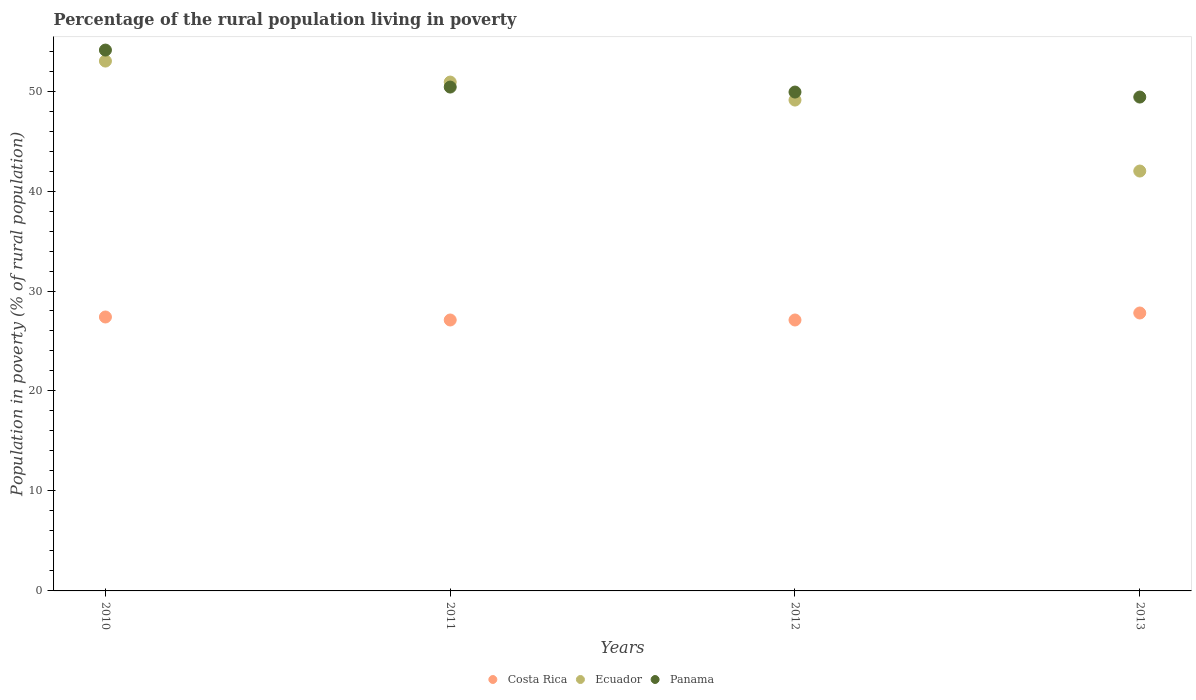Across all years, what is the maximum percentage of the rural population living in poverty in Costa Rica?
Provide a short and direct response. 27.8. Across all years, what is the minimum percentage of the rural population living in poverty in Panama?
Offer a very short reply. 49.4. What is the total percentage of the rural population living in poverty in Panama in the graph?
Your answer should be compact. 203.8. What is the difference between the percentage of the rural population living in poverty in Ecuador in 2010 and that in 2012?
Offer a very short reply. 3.9. What is the average percentage of the rural population living in poverty in Panama per year?
Keep it short and to the point. 50.95. In the year 2010, what is the difference between the percentage of the rural population living in poverty in Ecuador and percentage of the rural population living in poverty in Panama?
Provide a succinct answer. -1.1. What is the ratio of the percentage of the rural population living in poverty in Costa Rica in 2010 to that in 2011?
Your answer should be very brief. 1.01. Is the percentage of the rural population living in poverty in Ecuador in 2011 less than that in 2013?
Your answer should be very brief. No. Is the difference between the percentage of the rural population living in poverty in Ecuador in 2010 and 2012 greater than the difference between the percentage of the rural population living in poverty in Panama in 2010 and 2012?
Make the answer very short. No. What is the difference between the highest and the second highest percentage of the rural population living in poverty in Panama?
Ensure brevity in your answer.  3.7. In how many years, is the percentage of the rural population living in poverty in Panama greater than the average percentage of the rural population living in poverty in Panama taken over all years?
Keep it short and to the point. 1. Is it the case that in every year, the sum of the percentage of the rural population living in poverty in Costa Rica and percentage of the rural population living in poverty in Ecuador  is greater than the percentage of the rural population living in poverty in Panama?
Give a very brief answer. Yes. Is the percentage of the rural population living in poverty in Ecuador strictly greater than the percentage of the rural population living in poverty in Panama over the years?
Your answer should be very brief. No. How many dotlines are there?
Offer a very short reply. 3. How many years are there in the graph?
Offer a terse response. 4. Does the graph contain grids?
Make the answer very short. No. Where does the legend appear in the graph?
Provide a succinct answer. Bottom center. How are the legend labels stacked?
Your answer should be compact. Horizontal. What is the title of the graph?
Your answer should be very brief. Percentage of the rural population living in poverty. What is the label or title of the Y-axis?
Your response must be concise. Population in poverty (% of rural population). What is the Population in poverty (% of rural population) of Costa Rica in 2010?
Your response must be concise. 27.4. What is the Population in poverty (% of rural population) of Panama in 2010?
Provide a succinct answer. 54.1. What is the Population in poverty (% of rural population) of Costa Rica in 2011?
Make the answer very short. 27.1. What is the Population in poverty (% of rural population) of Ecuador in 2011?
Give a very brief answer. 50.9. What is the Population in poverty (% of rural population) in Panama in 2011?
Provide a short and direct response. 50.4. What is the Population in poverty (% of rural population) in Costa Rica in 2012?
Your response must be concise. 27.1. What is the Population in poverty (% of rural population) in Ecuador in 2012?
Ensure brevity in your answer.  49.1. What is the Population in poverty (% of rural population) of Panama in 2012?
Ensure brevity in your answer.  49.9. What is the Population in poverty (% of rural population) of Costa Rica in 2013?
Your answer should be very brief. 27.8. What is the Population in poverty (% of rural population) of Panama in 2013?
Make the answer very short. 49.4. Across all years, what is the maximum Population in poverty (% of rural population) of Costa Rica?
Your answer should be very brief. 27.8. Across all years, what is the maximum Population in poverty (% of rural population) in Ecuador?
Provide a short and direct response. 53. Across all years, what is the maximum Population in poverty (% of rural population) in Panama?
Offer a very short reply. 54.1. Across all years, what is the minimum Population in poverty (% of rural population) of Costa Rica?
Offer a terse response. 27.1. Across all years, what is the minimum Population in poverty (% of rural population) in Ecuador?
Make the answer very short. 42. Across all years, what is the minimum Population in poverty (% of rural population) of Panama?
Make the answer very short. 49.4. What is the total Population in poverty (% of rural population) in Costa Rica in the graph?
Make the answer very short. 109.4. What is the total Population in poverty (% of rural population) in Ecuador in the graph?
Your answer should be compact. 195. What is the total Population in poverty (% of rural population) of Panama in the graph?
Your response must be concise. 203.8. What is the difference between the Population in poverty (% of rural population) in Costa Rica in 2010 and that in 2011?
Make the answer very short. 0.3. What is the difference between the Population in poverty (% of rural population) in Panama in 2010 and that in 2011?
Ensure brevity in your answer.  3.7. What is the difference between the Population in poverty (% of rural population) of Costa Rica in 2010 and that in 2012?
Offer a terse response. 0.3. What is the difference between the Population in poverty (% of rural population) of Ecuador in 2010 and that in 2012?
Your answer should be very brief. 3.9. What is the difference between the Population in poverty (% of rural population) in Costa Rica in 2010 and that in 2013?
Offer a terse response. -0.4. What is the difference between the Population in poverty (% of rural population) in Panama in 2010 and that in 2013?
Keep it short and to the point. 4.7. What is the difference between the Population in poverty (% of rural population) in Costa Rica in 2011 and that in 2012?
Your answer should be compact. 0. What is the difference between the Population in poverty (% of rural population) of Ecuador in 2011 and that in 2012?
Your response must be concise. 1.8. What is the difference between the Population in poverty (% of rural population) of Panama in 2011 and that in 2012?
Ensure brevity in your answer.  0.5. What is the difference between the Population in poverty (% of rural population) of Ecuador in 2011 and that in 2013?
Your response must be concise. 8.9. What is the difference between the Population in poverty (% of rural population) of Costa Rica in 2012 and that in 2013?
Provide a succinct answer. -0.7. What is the difference between the Population in poverty (% of rural population) in Ecuador in 2012 and that in 2013?
Ensure brevity in your answer.  7.1. What is the difference between the Population in poverty (% of rural population) of Panama in 2012 and that in 2013?
Offer a very short reply. 0.5. What is the difference between the Population in poverty (% of rural population) in Costa Rica in 2010 and the Population in poverty (% of rural population) in Ecuador in 2011?
Offer a terse response. -23.5. What is the difference between the Population in poverty (% of rural population) of Costa Rica in 2010 and the Population in poverty (% of rural population) of Panama in 2011?
Give a very brief answer. -23. What is the difference between the Population in poverty (% of rural population) of Ecuador in 2010 and the Population in poverty (% of rural population) of Panama in 2011?
Provide a succinct answer. 2.6. What is the difference between the Population in poverty (% of rural population) of Costa Rica in 2010 and the Population in poverty (% of rural population) of Ecuador in 2012?
Your response must be concise. -21.7. What is the difference between the Population in poverty (% of rural population) of Costa Rica in 2010 and the Population in poverty (% of rural population) of Panama in 2012?
Make the answer very short. -22.5. What is the difference between the Population in poverty (% of rural population) in Costa Rica in 2010 and the Population in poverty (% of rural population) in Ecuador in 2013?
Your response must be concise. -14.6. What is the difference between the Population in poverty (% of rural population) in Costa Rica in 2011 and the Population in poverty (% of rural population) in Ecuador in 2012?
Your answer should be very brief. -22. What is the difference between the Population in poverty (% of rural population) in Costa Rica in 2011 and the Population in poverty (% of rural population) in Panama in 2012?
Ensure brevity in your answer.  -22.8. What is the difference between the Population in poverty (% of rural population) in Costa Rica in 2011 and the Population in poverty (% of rural population) in Ecuador in 2013?
Your answer should be very brief. -14.9. What is the difference between the Population in poverty (% of rural population) of Costa Rica in 2011 and the Population in poverty (% of rural population) of Panama in 2013?
Offer a very short reply. -22.3. What is the difference between the Population in poverty (% of rural population) in Costa Rica in 2012 and the Population in poverty (% of rural population) in Ecuador in 2013?
Your answer should be compact. -14.9. What is the difference between the Population in poverty (% of rural population) of Costa Rica in 2012 and the Population in poverty (% of rural population) of Panama in 2013?
Provide a succinct answer. -22.3. What is the difference between the Population in poverty (% of rural population) in Ecuador in 2012 and the Population in poverty (% of rural population) in Panama in 2013?
Provide a short and direct response. -0.3. What is the average Population in poverty (% of rural population) in Costa Rica per year?
Offer a terse response. 27.35. What is the average Population in poverty (% of rural population) in Ecuador per year?
Offer a terse response. 48.75. What is the average Population in poverty (% of rural population) of Panama per year?
Offer a terse response. 50.95. In the year 2010, what is the difference between the Population in poverty (% of rural population) in Costa Rica and Population in poverty (% of rural population) in Ecuador?
Offer a very short reply. -25.6. In the year 2010, what is the difference between the Population in poverty (% of rural population) of Costa Rica and Population in poverty (% of rural population) of Panama?
Make the answer very short. -26.7. In the year 2011, what is the difference between the Population in poverty (% of rural population) in Costa Rica and Population in poverty (% of rural population) in Ecuador?
Your answer should be very brief. -23.8. In the year 2011, what is the difference between the Population in poverty (% of rural population) of Costa Rica and Population in poverty (% of rural population) of Panama?
Your response must be concise. -23.3. In the year 2011, what is the difference between the Population in poverty (% of rural population) in Ecuador and Population in poverty (% of rural population) in Panama?
Ensure brevity in your answer.  0.5. In the year 2012, what is the difference between the Population in poverty (% of rural population) of Costa Rica and Population in poverty (% of rural population) of Ecuador?
Offer a very short reply. -22. In the year 2012, what is the difference between the Population in poverty (% of rural population) of Costa Rica and Population in poverty (% of rural population) of Panama?
Make the answer very short. -22.8. In the year 2013, what is the difference between the Population in poverty (% of rural population) in Costa Rica and Population in poverty (% of rural population) in Panama?
Ensure brevity in your answer.  -21.6. What is the ratio of the Population in poverty (% of rural population) in Costa Rica in 2010 to that in 2011?
Your answer should be compact. 1.01. What is the ratio of the Population in poverty (% of rural population) in Ecuador in 2010 to that in 2011?
Ensure brevity in your answer.  1.04. What is the ratio of the Population in poverty (% of rural population) in Panama in 2010 to that in 2011?
Provide a succinct answer. 1.07. What is the ratio of the Population in poverty (% of rural population) in Costa Rica in 2010 to that in 2012?
Your answer should be very brief. 1.01. What is the ratio of the Population in poverty (% of rural population) in Ecuador in 2010 to that in 2012?
Your answer should be very brief. 1.08. What is the ratio of the Population in poverty (% of rural population) of Panama in 2010 to that in 2012?
Provide a succinct answer. 1.08. What is the ratio of the Population in poverty (% of rural population) in Costa Rica in 2010 to that in 2013?
Make the answer very short. 0.99. What is the ratio of the Population in poverty (% of rural population) in Ecuador in 2010 to that in 2013?
Your response must be concise. 1.26. What is the ratio of the Population in poverty (% of rural population) in Panama in 2010 to that in 2013?
Offer a terse response. 1.1. What is the ratio of the Population in poverty (% of rural population) in Costa Rica in 2011 to that in 2012?
Your answer should be very brief. 1. What is the ratio of the Population in poverty (% of rural population) of Ecuador in 2011 to that in 2012?
Offer a terse response. 1.04. What is the ratio of the Population in poverty (% of rural population) in Costa Rica in 2011 to that in 2013?
Ensure brevity in your answer.  0.97. What is the ratio of the Population in poverty (% of rural population) of Ecuador in 2011 to that in 2013?
Your response must be concise. 1.21. What is the ratio of the Population in poverty (% of rural population) in Panama in 2011 to that in 2013?
Your response must be concise. 1.02. What is the ratio of the Population in poverty (% of rural population) in Costa Rica in 2012 to that in 2013?
Your answer should be very brief. 0.97. What is the ratio of the Population in poverty (% of rural population) of Ecuador in 2012 to that in 2013?
Give a very brief answer. 1.17. What is the ratio of the Population in poverty (% of rural population) of Panama in 2012 to that in 2013?
Your response must be concise. 1.01. What is the difference between the highest and the second highest Population in poverty (% of rural population) of Costa Rica?
Make the answer very short. 0.4. What is the difference between the highest and the second highest Population in poverty (% of rural population) of Ecuador?
Make the answer very short. 2.1. What is the difference between the highest and the second highest Population in poverty (% of rural population) of Panama?
Your answer should be very brief. 3.7. What is the difference between the highest and the lowest Population in poverty (% of rural population) in Costa Rica?
Make the answer very short. 0.7. What is the difference between the highest and the lowest Population in poverty (% of rural population) in Panama?
Make the answer very short. 4.7. 